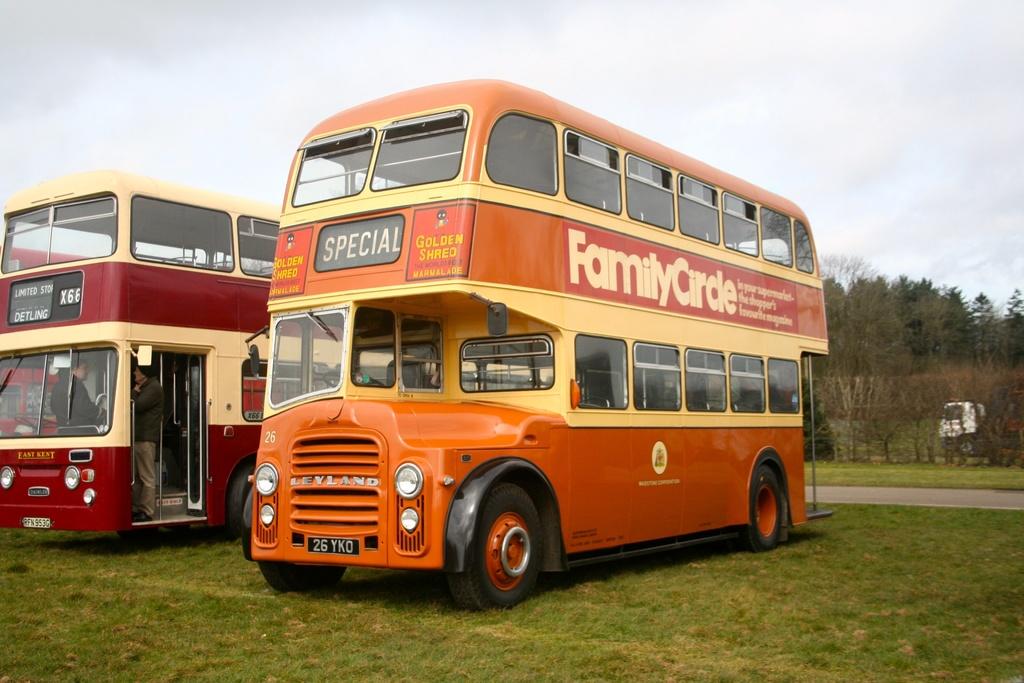What kind of circle does the bus advertise?
Provide a succinct answer. Family. What brand of marmalade is advertised on the orange bus?
Your answer should be very brief. Golden shred. 